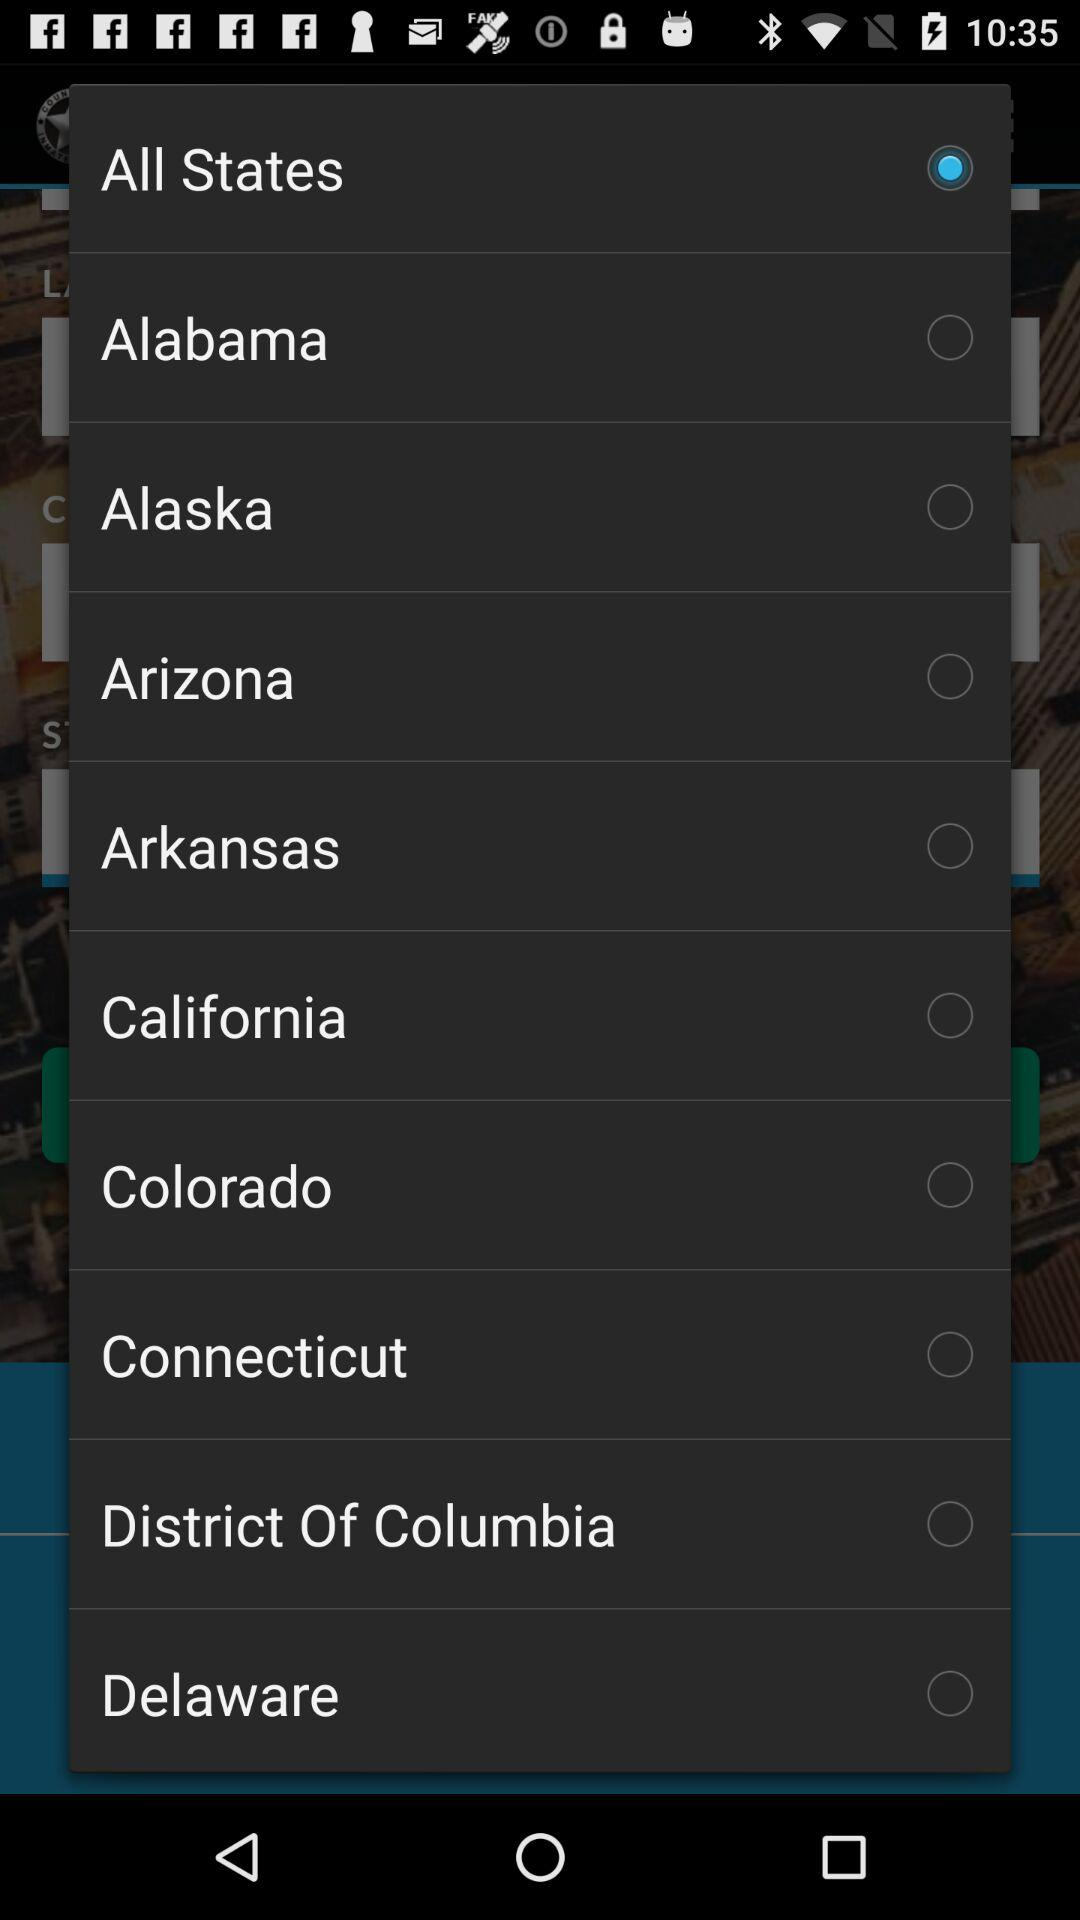Is "Alaska" selected or not? "Alaska" is not selected. 